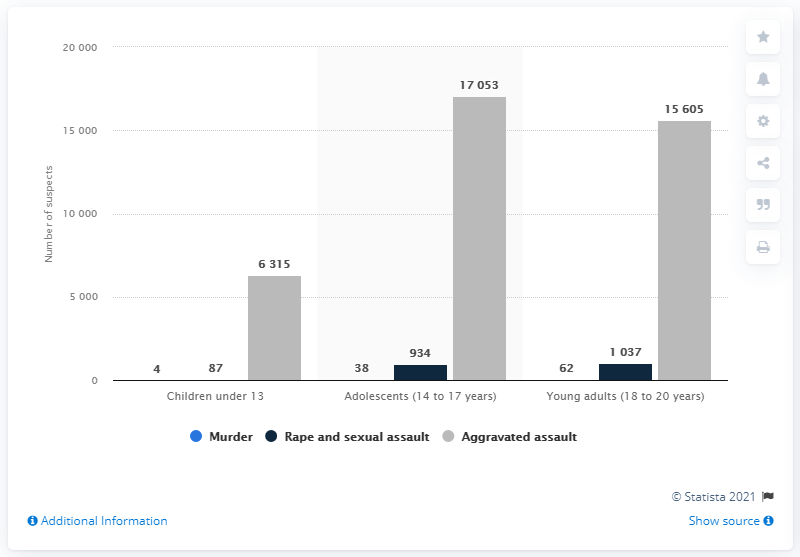Draw attention to some important aspects in this diagram. In 2020, it is estimated that 38 adolescents in Germany were suspected of committing murder. In 2020, it is estimated that 934 adolescents in Germany were suspected of committing rape or sexual assault. 